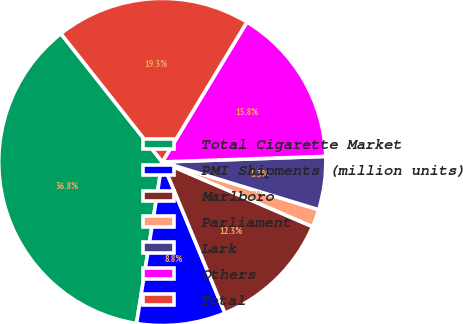Convert chart. <chart><loc_0><loc_0><loc_500><loc_500><pie_chart><fcel>Total Cigarette Market<fcel>PMI Shipments (million units)<fcel>Marlboro<fcel>Parliament<fcel>Lark<fcel>Others<fcel>Total<nl><fcel>36.84%<fcel>8.77%<fcel>12.28%<fcel>1.75%<fcel>5.26%<fcel>15.79%<fcel>19.3%<nl></chart> 